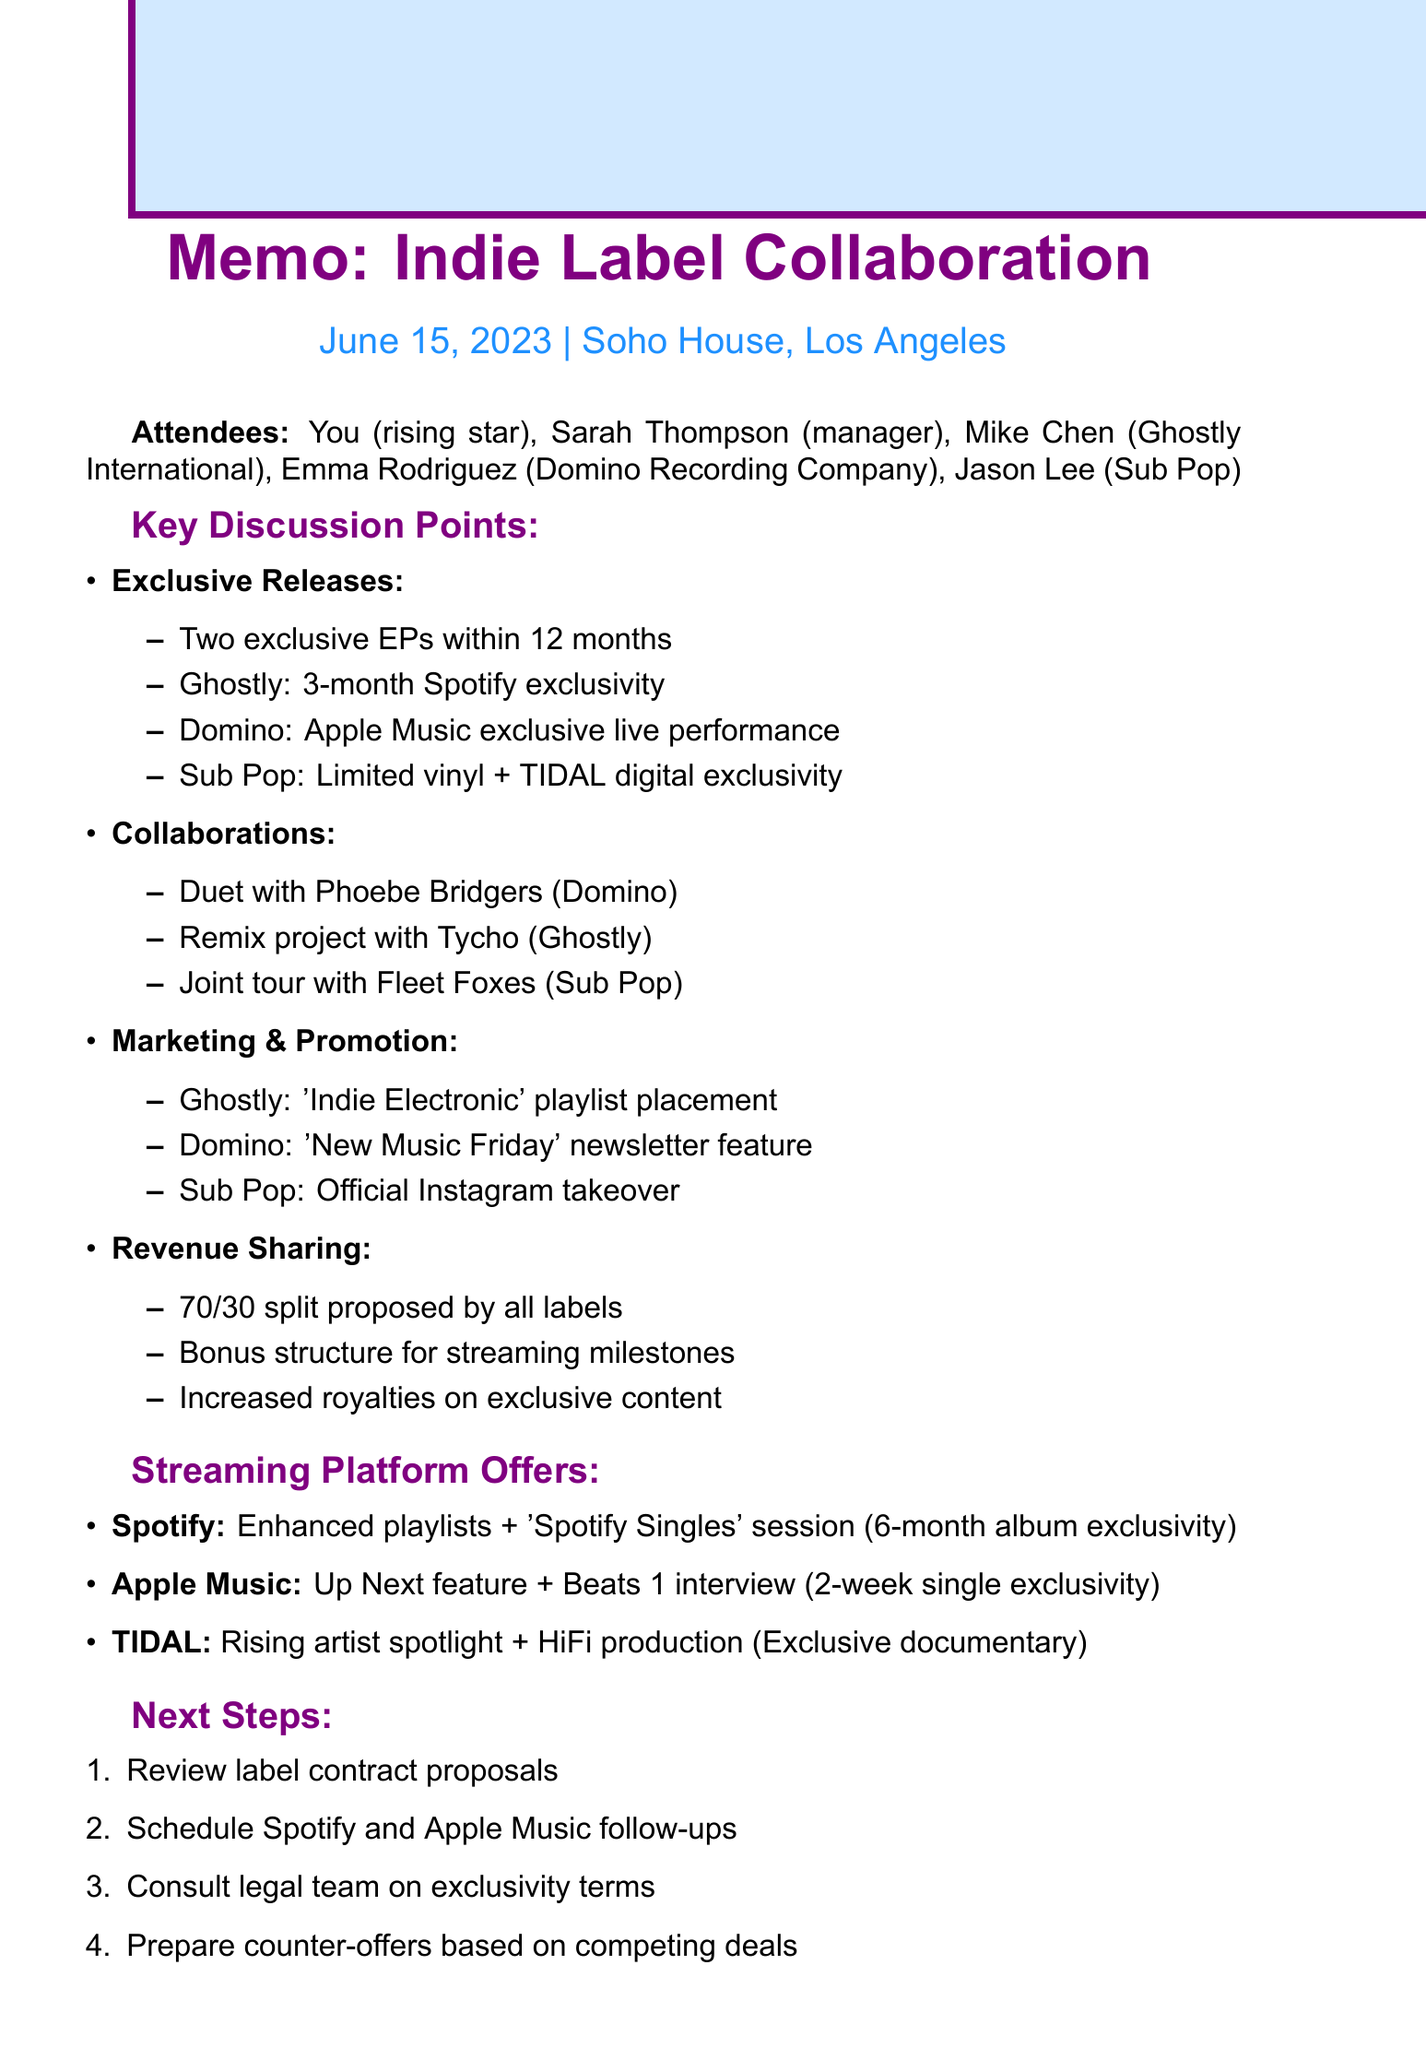What was the date of the meeting? The document states the meeting took place on June 15, 2023.
Answer: June 15, 2023 Who represented Ghostly International? Mike Chen is listed as the representative from Ghostly International in the attendee section.
Answer: Mike Chen What exclusivity period did Ghostly International propose for the Spotify release? The proposal from Ghostly International includes a 3-month exclusivity window for Spotify.
Answer: 3-month What is the proposed revenue share split for the labels? The document mentions a standard 70/30 split proposed by all labels.
Answer: 70/30 Which artist is suggested for a duet in collaboration? The duet collaboration proposal includes Phoebe Bridgers, an artist from Domino.
Answer: Phoebe Bridgers What was Domino's marketing proposal? The proposal from Domino includes a feature in their 'New Music Friday' newsletter.
Answer: 'New Music Friday' What is the next step regarding the follow-up meetings? The next step includes scheduling follow-up meetings with Spotify and Apple Music representatives.
Answer: Schedule follow-up meetings What does TIDAL offer for exclusive content? TIDAL's offer includes a Rising artist spotlight and HiFi audio master production.
Answer: Rising artist spotlight and HiFi production What collaborative project involves Tycho? The document suggests a remix project involving Tycho, an artist from Ghostly International.
Answer: Remix project with Tycho 